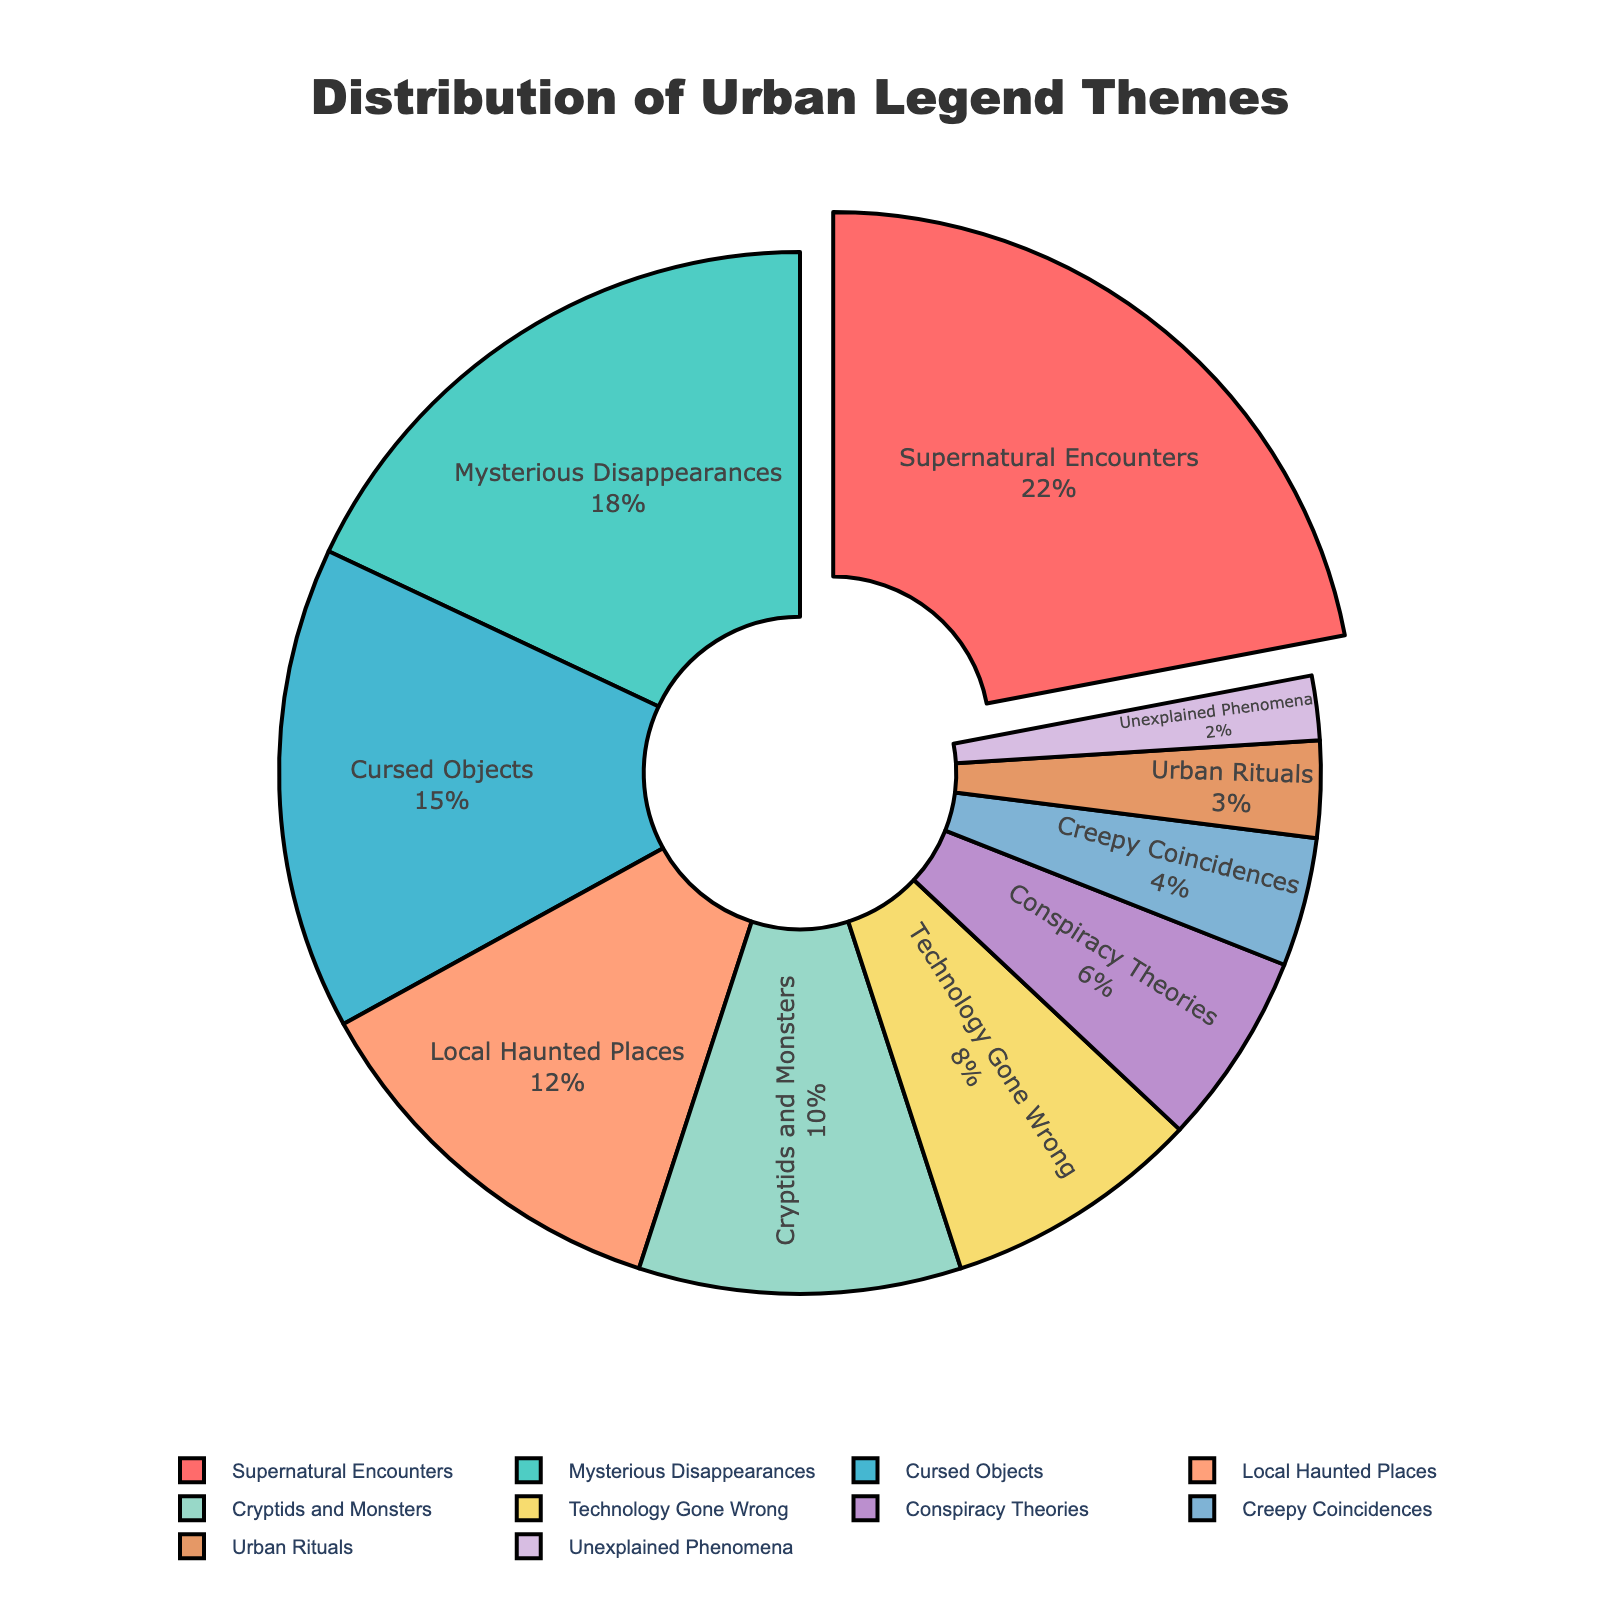What is the most common urban legend theme? The largest section of the pie chart represents the most common theme, which is also pulled out slightly from the chart. This section is labeled "Supernatural Encounters" with 22%.
Answer: Supernatural Encounters Which urban legend theme has the smallest percentage? The smallest slice in the pie chart represents the theme with the smallest percentage. This slice is labeled "Unexplained Phenomena" with 2%.
Answer: Unexplained Phenomena Compare the percentage of "Local Haunted Places" to the percentage of "Cursed Objects". The pie chart shows 12% for "Local Haunted Places" and 15% for "Cursed Objects". Thus, "Cursed Objects" has a higher percentage.
Answer: Cursed Objects What is the combined percentage of "Conspiracy Theories" and "Creepy Coincidences"? "Conspiracy Theories" has 6% and "Creepy Coincidences" has 4%. Adding these two percentages together results in 6% + 4% = 10%.
Answer: 10% How much larger is the "Supernatural Encounters" segment compared to the "Technology Gone Wrong" segment? "Supernatural Encounters" is 22% while "Technology Gone Wrong" is 8%. The difference is 22% - 8% = 14%.
Answer: 14% Between the themes "Cryptids and Monsters" and "Mysterious Disappearances", which is more popular and by how much? "Mysterious Disappearances" is 18% and "Cryptids and Monsters" is 10%, so "Mysterious Disappearances" is more popular by 18% - 10% = 8%.
Answer: Mysterious Disappearances by 8% What is the cumulative percentage of themes with less than 10%? The themes are "Technology Gone Wrong" (8%), "Conspiracy Theories" (6%), "Creepy Coincidences" (4%), "Urban Rituals" (3%), and "Unexplained Phenomena" (2%). Adding these together gives 8% + 6% + 4% + 3% + 2% = 23%.
Answer: 23% What color represents the "Local Haunted Places" theme? The pie chart uses different colors for different sections, and "Local Haunted Places" is shown in a color that looks similar to orange (fourth color in the legend).
Answer: Orange If you combine the percentages of themes related to creatures (Cryptids and Monsters, Supernatural Encounters), what would the total be? "Cryptids and Monsters" have 10% and "Supernatural Encounters" have 22%. Adding these two percentages together gives 10% + 22% = 32%.
Answer: 32% What proportion of the chart is taken up by both "Cursed Objects" and "Mysterious Disappearances" together? The chart shows 15% for "Cursed Objects" and 18% for "Mysterious Disappearances". Adding these together results in 15% + 18% = 33%.
Answer: 33% 